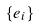Convert formula to latex. <formula><loc_0><loc_0><loc_500><loc_500>\{ e _ { i } \}</formula> 